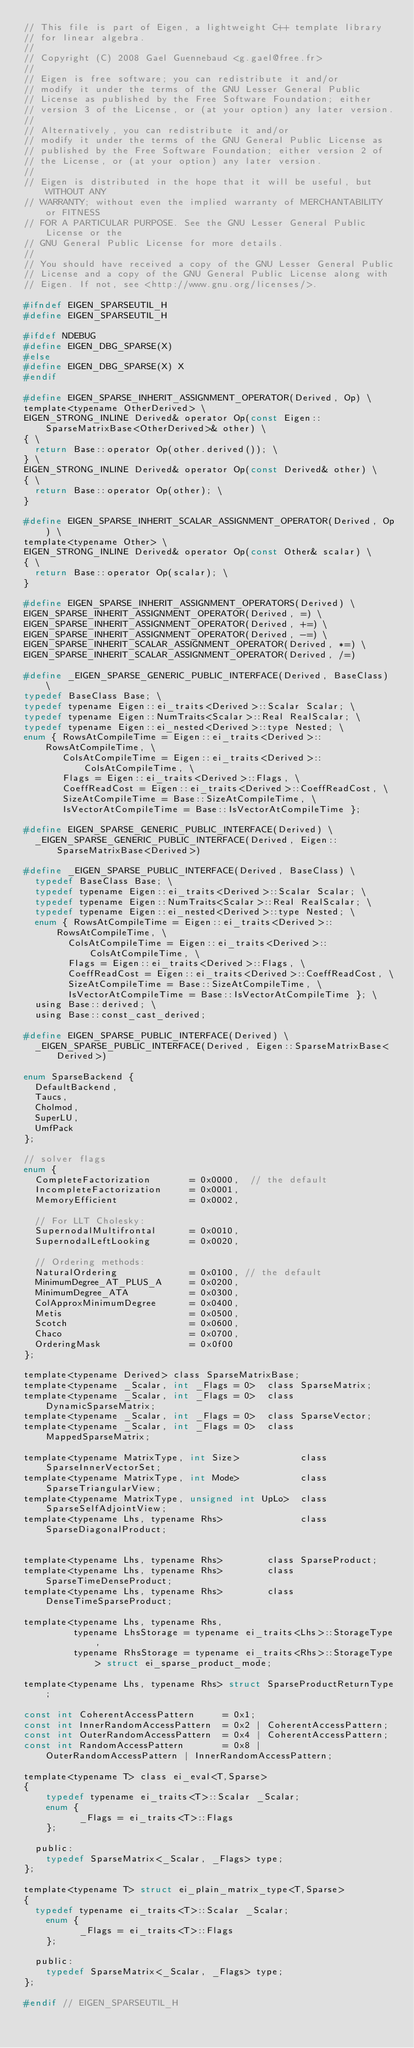Convert code to text. <code><loc_0><loc_0><loc_500><loc_500><_C_>// This file is part of Eigen, a lightweight C++ template library
// for linear algebra.
//
// Copyright (C) 2008 Gael Guennebaud <g.gael@free.fr>
//
// Eigen is free software; you can redistribute it and/or
// modify it under the terms of the GNU Lesser General Public
// License as published by the Free Software Foundation; either
// version 3 of the License, or (at your option) any later version.
//
// Alternatively, you can redistribute it and/or
// modify it under the terms of the GNU General Public License as
// published by the Free Software Foundation; either version 2 of
// the License, or (at your option) any later version.
//
// Eigen is distributed in the hope that it will be useful, but WITHOUT ANY
// WARRANTY; without even the implied warranty of MERCHANTABILITY or FITNESS
// FOR A PARTICULAR PURPOSE. See the GNU Lesser General Public License or the
// GNU General Public License for more details.
//
// You should have received a copy of the GNU Lesser General Public
// License and a copy of the GNU General Public License along with
// Eigen. If not, see <http://www.gnu.org/licenses/>.

#ifndef EIGEN_SPARSEUTIL_H
#define EIGEN_SPARSEUTIL_H

#ifdef NDEBUG
#define EIGEN_DBG_SPARSE(X)
#else
#define EIGEN_DBG_SPARSE(X) X
#endif

#define EIGEN_SPARSE_INHERIT_ASSIGNMENT_OPERATOR(Derived, Op) \
template<typename OtherDerived> \
EIGEN_STRONG_INLINE Derived& operator Op(const Eigen::SparseMatrixBase<OtherDerived>& other) \
{ \
  return Base::operator Op(other.derived()); \
} \
EIGEN_STRONG_INLINE Derived& operator Op(const Derived& other) \
{ \
  return Base::operator Op(other); \
}

#define EIGEN_SPARSE_INHERIT_SCALAR_ASSIGNMENT_OPERATOR(Derived, Op) \
template<typename Other> \
EIGEN_STRONG_INLINE Derived& operator Op(const Other& scalar) \
{ \
  return Base::operator Op(scalar); \
}

#define EIGEN_SPARSE_INHERIT_ASSIGNMENT_OPERATORS(Derived) \
EIGEN_SPARSE_INHERIT_ASSIGNMENT_OPERATOR(Derived, =) \
EIGEN_SPARSE_INHERIT_ASSIGNMENT_OPERATOR(Derived, +=) \
EIGEN_SPARSE_INHERIT_ASSIGNMENT_OPERATOR(Derived, -=) \
EIGEN_SPARSE_INHERIT_SCALAR_ASSIGNMENT_OPERATOR(Derived, *=) \
EIGEN_SPARSE_INHERIT_SCALAR_ASSIGNMENT_OPERATOR(Derived, /=)

#define _EIGEN_SPARSE_GENERIC_PUBLIC_INTERFACE(Derived, BaseClass) \
typedef BaseClass Base; \
typedef typename Eigen::ei_traits<Derived>::Scalar Scalar; \
typedef typename Eigen::NumTraits<Scalar>::Real RealScalar; \
typedef typename Eigen::ei_nested<Derived>::type Nested; \
enum { RowsAtCompileTime = Eigen::ei_traits<Derived>::RowsAtCompileTime, \
       ColsAtCompileTime = Eigen::ei_traits<Derived>::ColsAtCompileTime, \
       Flags = Eigen::ei_traits<Derived>::Flags, \
       CoeffReadCost = Eigen::ei_traits<Derived>::CoeffReadCost, \
       SizeAtCompileTime = Base::SizeAtCompileTime, \
       IsVectorAtCompileTime = Base::IsVectorAtCompileTime };

#define EIGEN_SPARSE_GENERIC_PUBLIC_INTERFACE(Derived) \
  _EIGEN_SPARSE_GENERIC_PUBLIC_INTERFACE(Derived, Eigen::SparseMatrixBase<Derived>)

#define _EIGEN_SPARSE_PUBLIC_INTERFACE(Derived, BaseClass) \
  typedef BaseClass Base; \
  typedef typename Eigen::ei_traits<Derived>::Scalar Scalar; \
  typedef typename Eigen::NumTraits<Scalar>::Real RealScalar; \
  typedef typename Eigen::ei_nested<Derived>::type Nested; \
  enum { RowsAtCompileTime = Eigen::ei_traits<Derived>::RowsAtCompileTime, \
        ColsAtCompileTime = Eigen::ei_traits<Derived>::ColsAtCompileTime, \
        Flags = Eigen::ei_traits<Derived>::Flags, \
        CoeffReadCost = Eigen::ei_traits<Derived>::CoeffReadCost, \
        SizeAtCompileTime = Base::SizeAtCompileTime, \
        IsVectorAtCompileTime = Base::IsVectorAtCompileTime }; \
  using Base::derived; \
  using Base::const_cast_derived;

#define EIGEN_SPARSE_PUBLIC_INTERFACE(Derived) \
  _EIGEN_SPARSE_PUBLIC_INTERFACE(Derived, Eigen::SparseMatrixBase<Derived>)

enum SparseBackend {
  DefaultBackend,
  Taucs,
  Cholmod,
  SuperLU,
  UmfPack
};

// solver flags
enum {
  CompleteFactorization       = 0x0000,  // the default
  IncompleteFactorization     = 0x0001,
  MemoryEfficient             = 0x0002,

  // For LLT Cholesky:
  SupernodalMultifrontal      = 0x0010,
  SupernodalLeftLooking       = 0x0020,

  // Ordering methods:
  NaturalOrdering             = 0x0100, // the default
  MinimumDegree_AT_PLUS_A     = 0x0200,
  MinimumDegree_ATA           = 0x0300,
  ColApproxMinimumDegree      = 0x0400,
  Metis                       = 0x0500,
  Scotch                      = 0x0600,
  Chaco                       = 0x0700,
  OrderingMask                = 0x0f00
};

template<typename Derived> class SparseMatrixBase;
template<typename _Scalar, int _Flags = 0>  class SparseMatrix;
template<typename _Scalar, int _Flags = 0>  class DynamicSparseMatrix;
template<typename _Scalar, int _Flags = 0>  class SparseVector;
template<typename _Scalar, int _Flags = 0>  class MappedSparseMatrix;

template<typename MatrixType, int Size>           class SparseInnerVectorSet;
template<typename MatrixType, int Mode>           class SparseTriangularView;
template<typename MatrixType, unsigned int UpLo>  class SparseSelfAdjointView;
template<typename Lhs, typename Rhs>              class SparseDiagonalProduct;


template<typename Lhs, typename Rhs>        class SparseProduct;
template<typename Lhs, typename Rhs>        class SparseTimeDenseProduct;
template<typename Lhs, typename Rhs>        class DenseTimeSparseProduct;

template<typename Lhs, typename Rhs,
         typename LhsStorage = typename ei_traits<Lhs>::StorageType,
         typename RhsStorage = typename ei_traits<Rhs>::StorageType> struct ei_sparse_product_mode;

template<typename Lhs, typename Rhs> struct SparseProductReturnType;

const int CoherentAccessPattern     = 0x1;
const int InnerRandomAccessPattern  = 0x2 | CoherentAccessPattern;
const int OuterRandomAccessPattern  = 0x4 | CoherentAccessPattern;
const int RandomAccessPattern       = 0x8 | OuterRandomAccessPattern | InnerRandomAccessPattern;

template<typename T> class ei_eval<T,Sparse>
{
    typedef typename ei_traits<T>::Scalar _Scalar;
    enum {
          _Flags = ei_traits<T>::Flags
    };

  public:
    typedef SparseMatrix<_Scalar, _Flags> type;
};

template<typename T> struct ei_plain_matrix_type<T,Sparse>
{
  typedef typename ei_traits<T>::Scalar _Scalar;
    enum {
          _Flags = ei_traits<T>::Flags
    };

  public:
    typedef SparseMatrix<_Scalar, _Flags> type;
};

#endif // EIGEN_SPARSEUTIL_H
</code> 